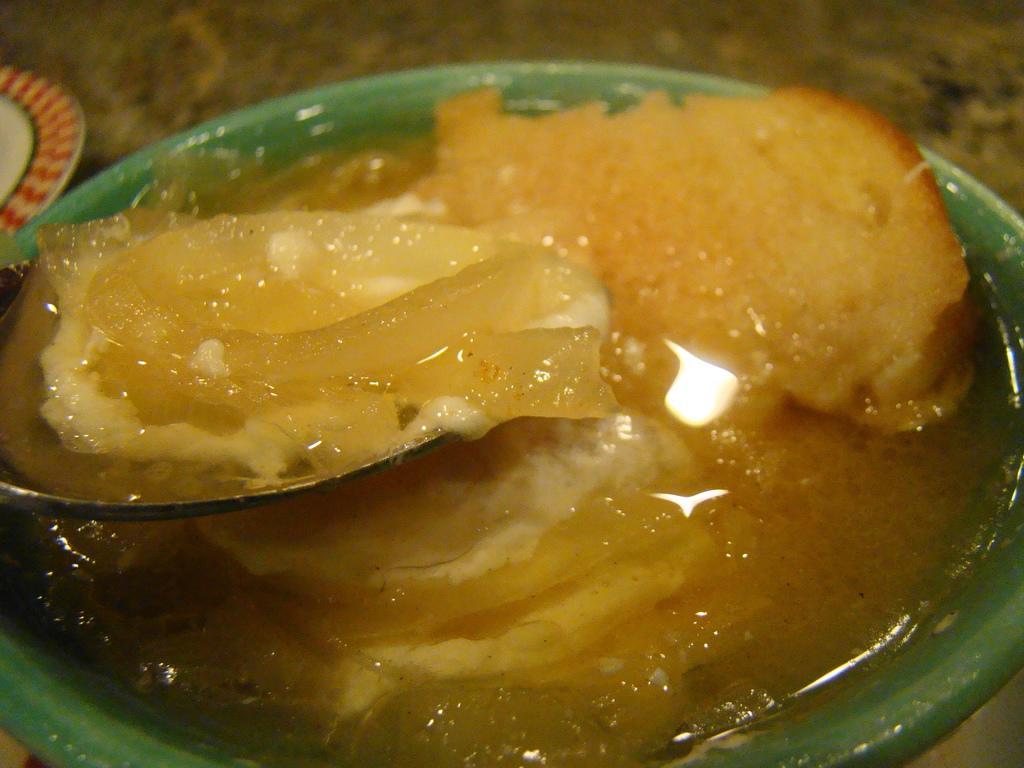Please provide a concise description of this image. In the image there is sweet in the bowl with a spoon in it, in the back there is a plate. 